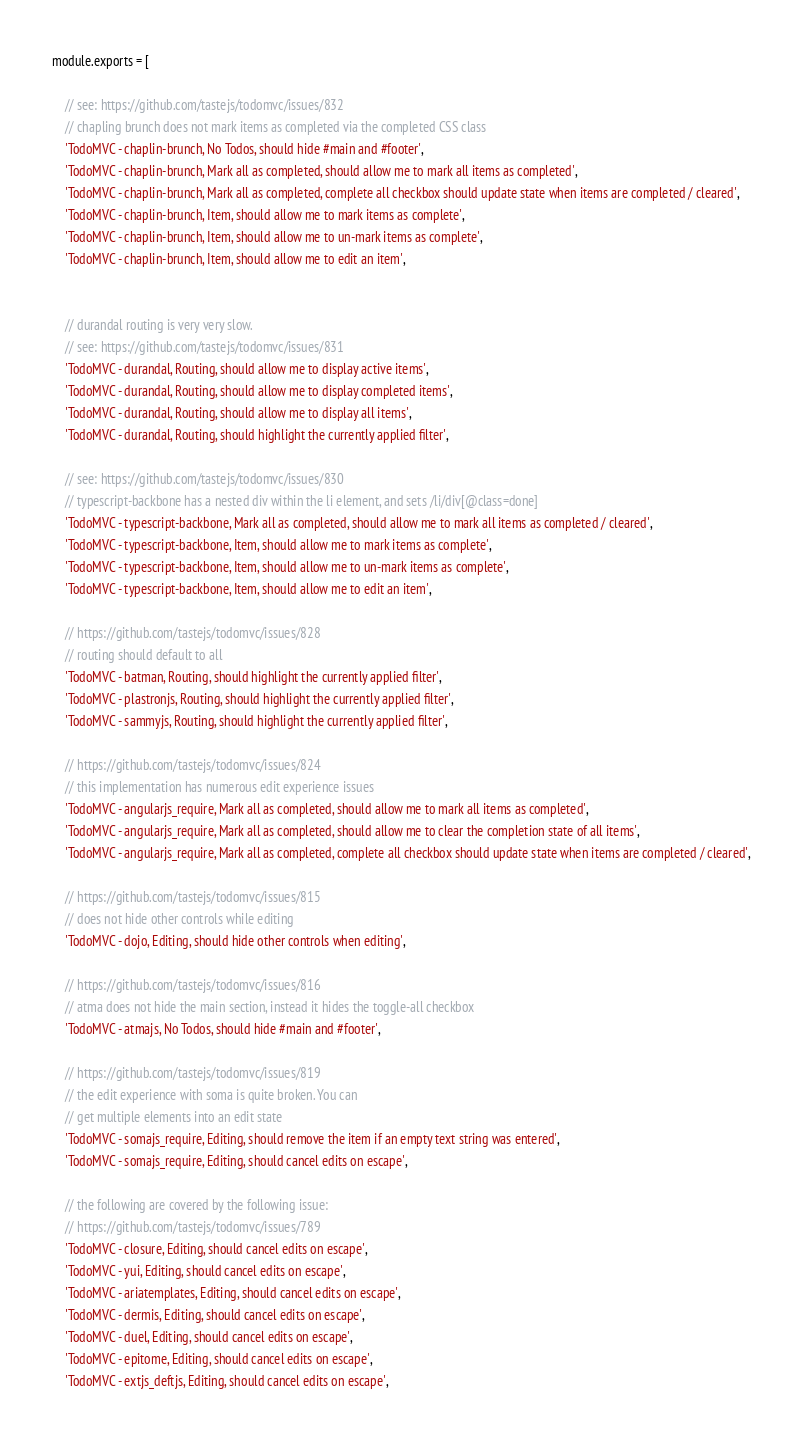<code> <loc_0><loc_0><loc_500><loc_500><_JavaScript_>module.exports = [

	// see: https://github.com/tastejs/todomvc/issues/832
	// chapling brunch does not mark items as completed via the completed CSS class
	'TodoMVC - chaplin-brunch, No Todos, should hide #main and #footer',
	'TodoMVC - chaplin-brunch, Mark all as completed, should allow me to mark all items as completed',
	'TodoMVC - chaplin-brunch, Mark all as completed, complete all checkbox should update state when items are completed / cleared',
	'TodoMVC - chaplin-brunch, Item, should allow me to mark items as complete',
	'TodoMVC - chaplin-brunch, Item, should allow me to un-mark items as complete',
	'TodoMVC - chaplin-brunch, Item, should allow me to edit an item',


	// durandal routing is very very slow.
	// see: https://github.com/tastejs/todomvc/issues/831
	'TodoMVC - durandal, Routing, should allow me to display active items',
	'TodoMVC - durandal, Routing, should allow me to display completed items',
	'TodoMVC - durandal, Routing, should allow me to display all items',
	'TodoMVC - durandal, Routing, should highlight the currently applied filter',

	// see: https://github.com/tastejs/todomvc/issues/830
	// typescript-backbone has a nested div within the li element, and sets /li/div[@class=done]
	'TodoMVC - typescript-backbone, Mark all as completed, should allow me to mark all items as completed / cleared',
	'TodoMVC - typescript-backbone, Item, should allow me to mark items as complete',
	'TodoMVC - typescript-backbone, Item, should allow me to un-mark items as complete',
	'TodoMVC - typescript-backbone, Item, should allow me to edit an item',

	// https://github.com/tastejs/todomvc/issues/828
	// routing should default to all
	'TodoMVC - batman, Routing, should highlight the currently applied filter',
	'TodoMVC - plastronjs, Routing, should highlight the currently applied filter',
	'TodoMVC - sammyjs, Routing, should highlight the currently applied filter',

	// https://github.com/tastejs/todomvc/issues/824
	// this implementation has numerous edit experience issues
	'TodoMVC - angularjs_require, Mark all as completed, should allow me to mark all items as completed',
	'TodoMVC - angularjs_require, Mark all as completed, should allow me to clear the completion state of all items',
	'TodoMVC - angularjs_require, Mark all as completed, complete all checkbox should update state when items are completed / cleared',

	// https://github.com/tastejs/todomvc/issues/815
	// does not hide other controls while editing
	'TodoMVC - dojo, Editing, should hide other controls when editing',

	// https://github.com/tastejs/todomvc/issues/816
	// atma does not hide the main section, instead it hides the toggle-all checkbox
	'TodoMVC - atmajs, No Todos, should hide #main and #footer',

	// https://github.com/tastejs/todomvc/issues/819
	// the edit experience with soma is quite broken. You can
	// get multiple elements into an edit state
	'TodoMVC - somajs_require, Editing, should remove the item if an empty text string was entered',
	'TodoMVC - somajs_require, Editing, should cancel edits on escape',

	// the following are covered by the following issue:
	// https://github.com/tastejs/todomvc/issues/789
	'TodoMVC - closure, Editing, should cancel edits on escape',
	'TodoMVC - yui, Editing, should cancel edits on escape',
	'TodoMVC - ariatemplates, Editing, should cancel edits on escape',
	'TodoMVC - dermis, Editing, should cancel edits on escape',
	'TodoMVC - duel, Editing, should cancel edits on escape',
	'TodoMVC - epitome, Editing, should cancel edits on escape',
	'TodoMVC - extjs_deftjs, Editing, should cancel edits on escape',</code> 